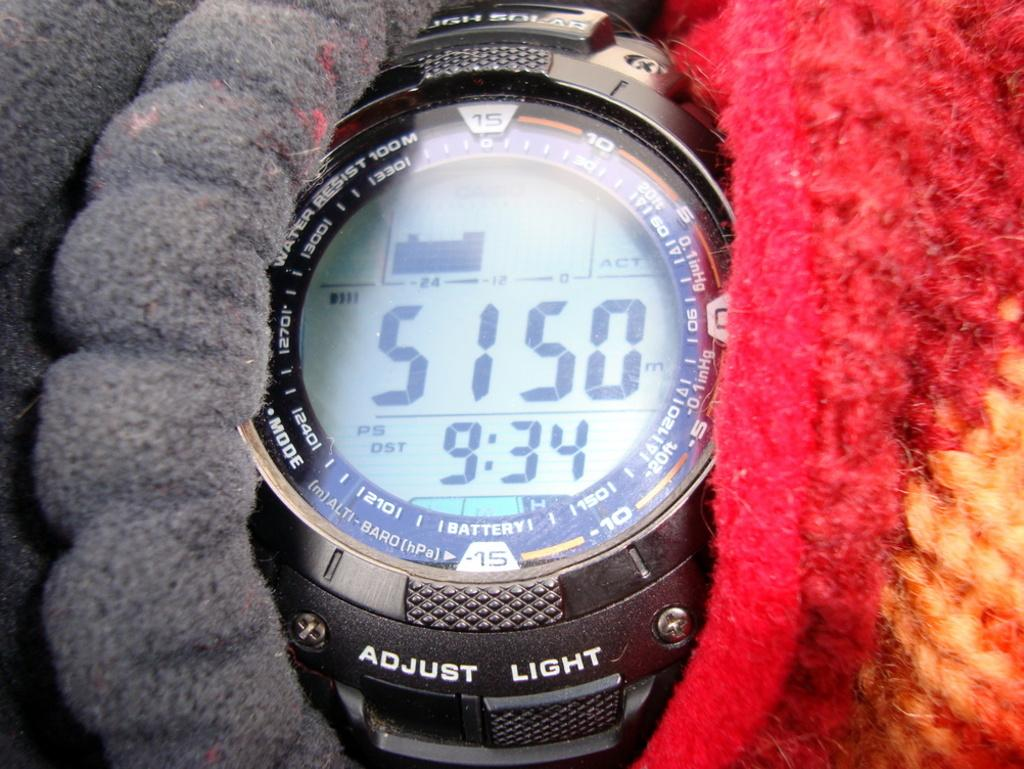Provide a one-sentence caption for the provided image. Face of a watch which says "Adjust Light" near the bottom. 